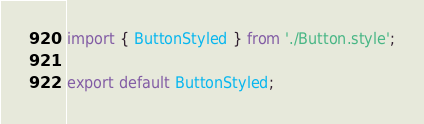Convert code to text. <code><loc_0><loc_0><loc_500><loc_500><_TypeScript_>import { ButtonStyled } from './Button.style';

export default ButtonStyled;</code> 